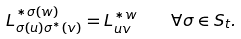Convert formula to latex. <formula><loc_0><loc_0><loc_500><loc_500>L ^ { * \sigma ( w ) } _ { \sigma ( u ) \sigma ^ { * } ( v ) } = L ^ { * w } _ { u v } \quad \forall \sigma \in S _ { t } .</formula> 